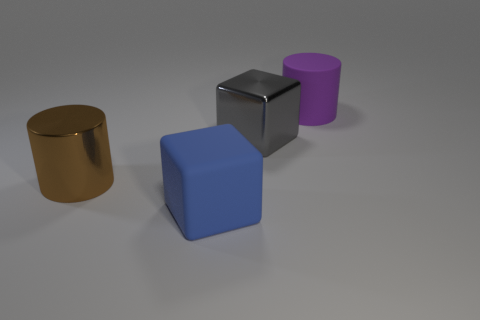Is there anything else that has the same color as the large shiny cylinder?
Give a very brief answer. No. What shape is the other big thing that is the same material as the large brown object?
Ensure brevity in your answer.  Cube. There is a large brown metallic object; is its shape the same as the big metal object on the right side of the big brown shiny cylinder?
Offer a terse response. No. What material is the big cylinder that is right of the object in front of the brown metallic cylinder?
Ensure brevity in your answer.  Rubber. Are there an equal number of large gray cubes that are in front of the big gray metal cube and tiny yellow cylinders?
Provide a short and direct response. Yes. How many big objects are both to the right of the brown object and to the left of the purple cylinder?
Keep it short and to the point. 2. How many other things are the same shape as the large blue matte thing?
Your response must be concise. 1. Is the number of large objects that are in front of the big gray metal cube greater than the number of large green things?
Make the answer very short. Yes. What is the color of the large block that is in front of the big gray shiny thing?
Offer a terse response. Blue. What number of matte things are either cylinders or blue things?
Provide a succinct answer. 2. 